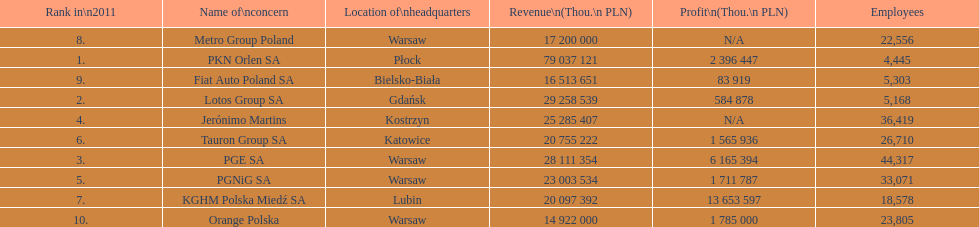How many companies had over $1,000,000 profit? 6. 